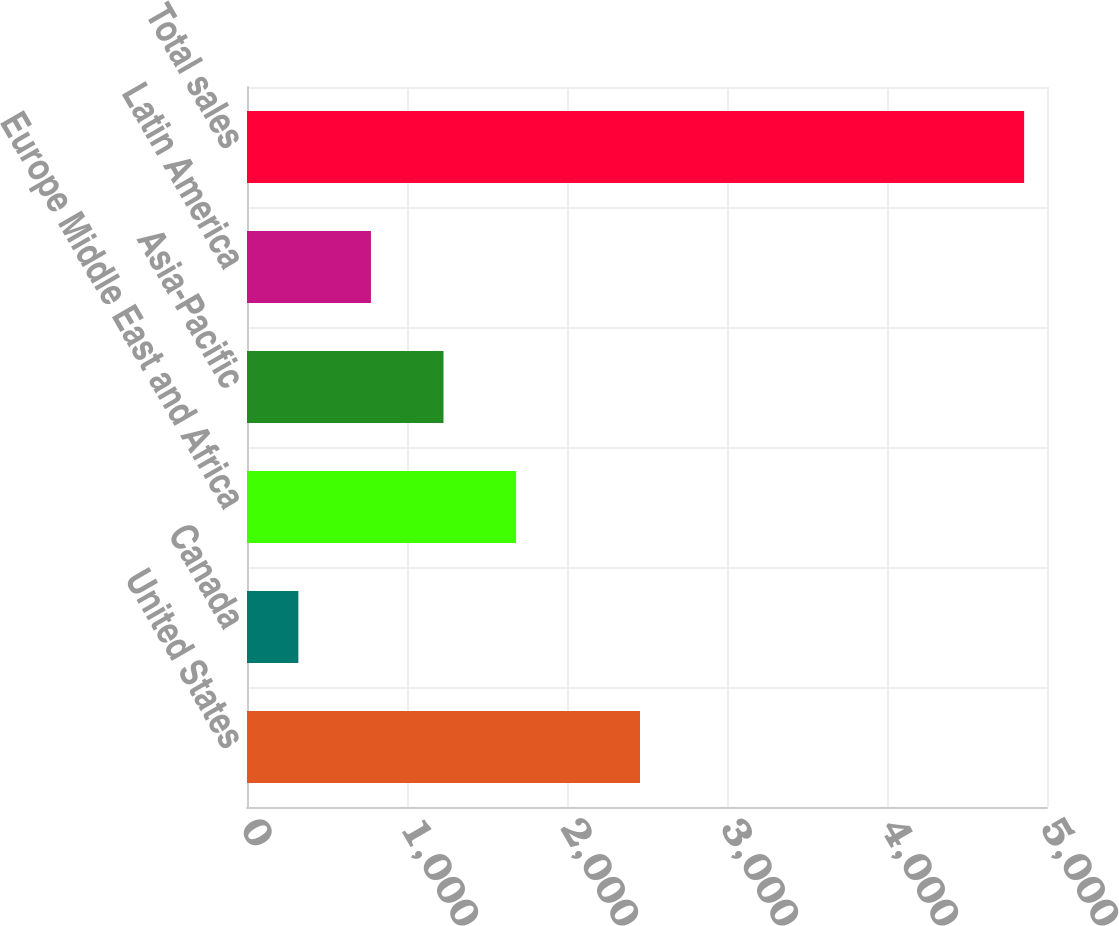Convert chart. <chart><loc_0><loc_0><loc_500><loc_500><bar_chart><fcel>United States<fcel>Canada<fcel>Europe Middle East and Africa<fcel>Asia-Pacific<fcel>Latin America<fcel>Total sales<nl><fcel>2456.2<fcel>321<fcel>1681.8<fcel>1228.2<fcel>774.6<fcel>4857<nl></chart> 